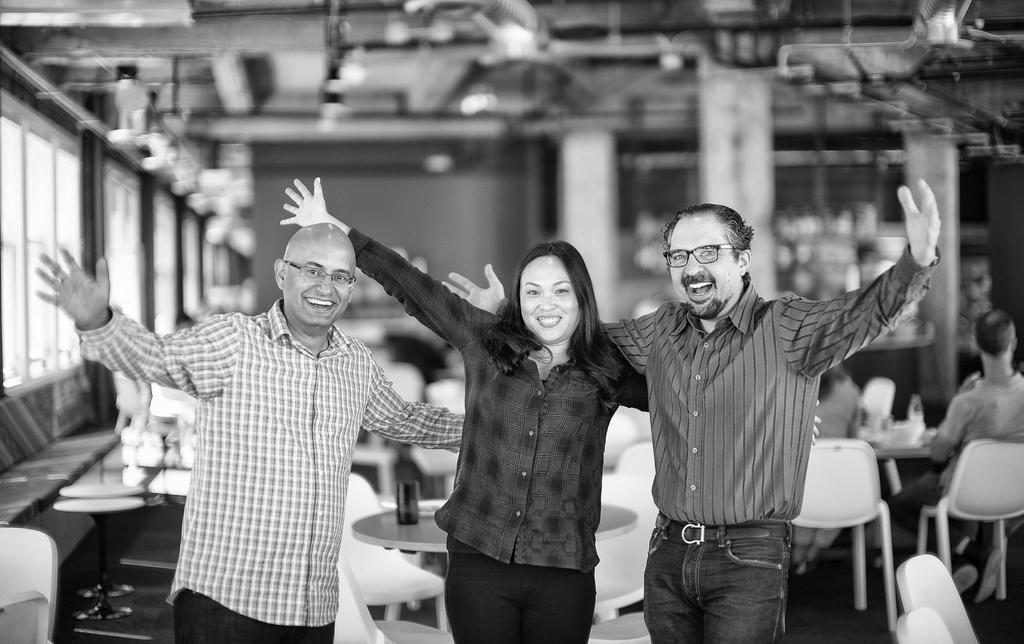Could you give a brief overview of what you see in this image? In this image i can see two men and a women they are standing and laughing, at the background i can see a chair, a table few persons are sitting,i can also see the pillar and a wall. 